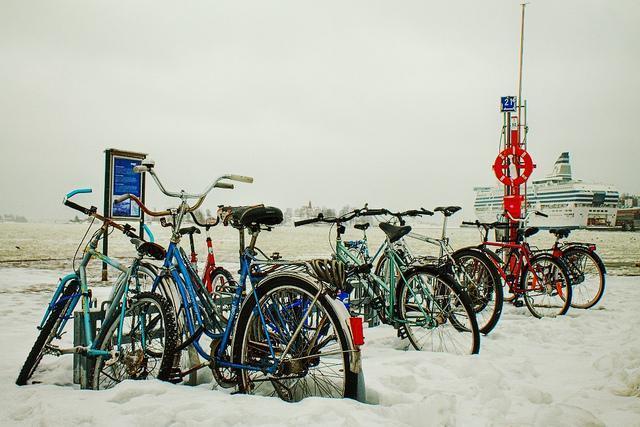How many bikes are in the picture?
Give a very brief answer. 8. How many bicycles are there?
Give a very brief answer. 7. How many people are wearing a blue snow suit?
Give a very brief answer. 0. 